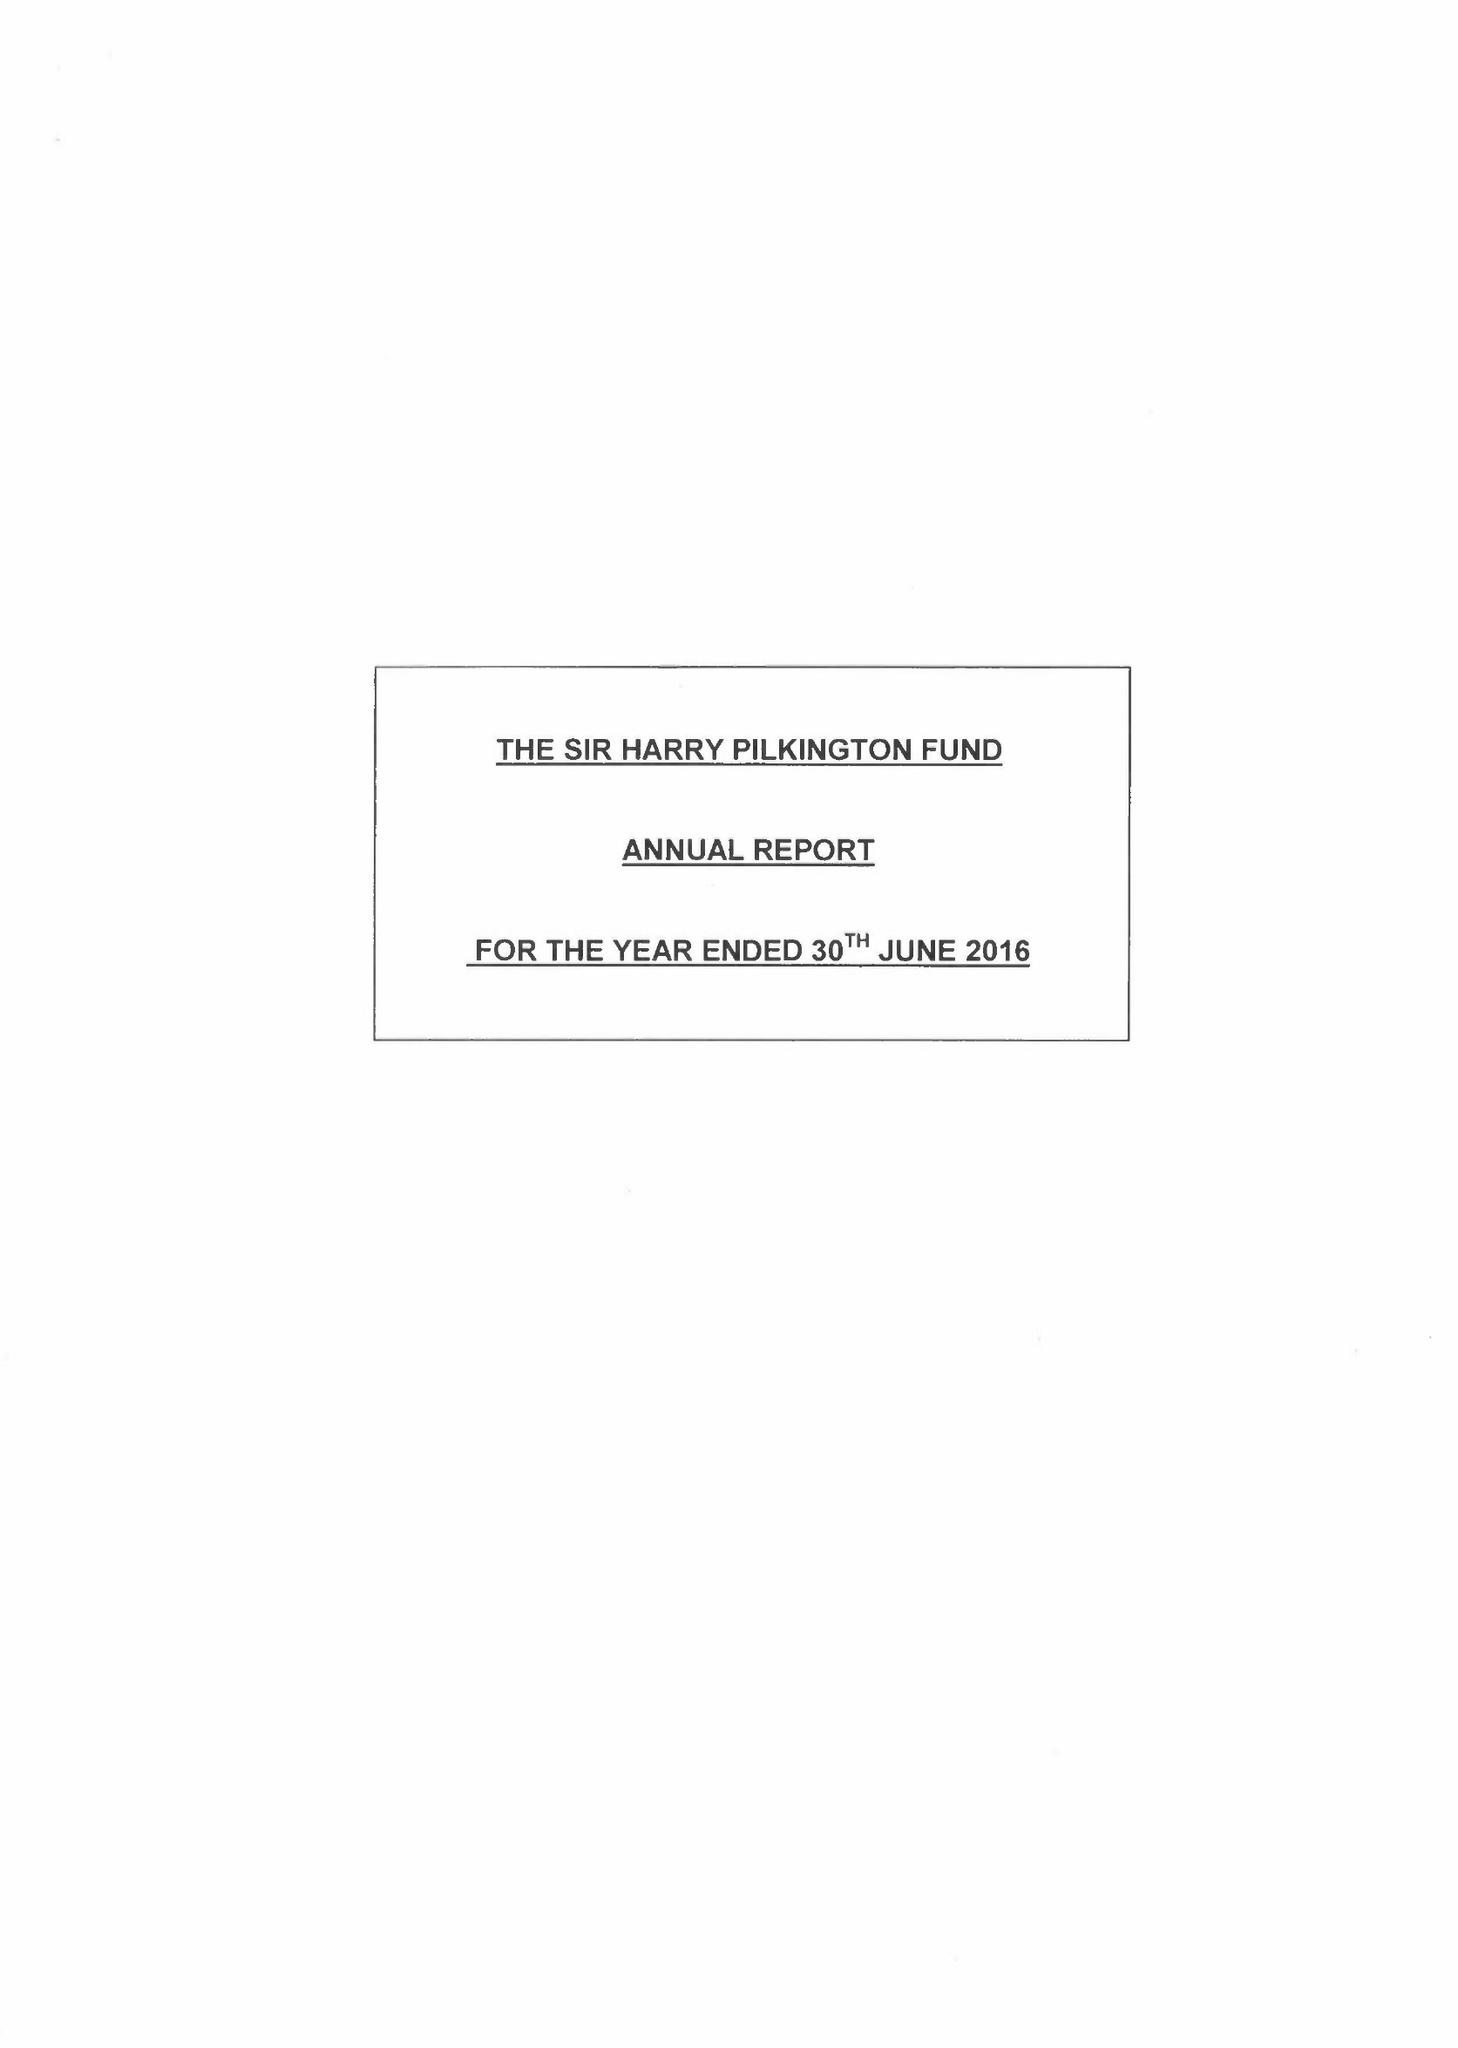What is the value for the address__post_town?
Answer the question using a single word or phrase. LIVERPOOL 